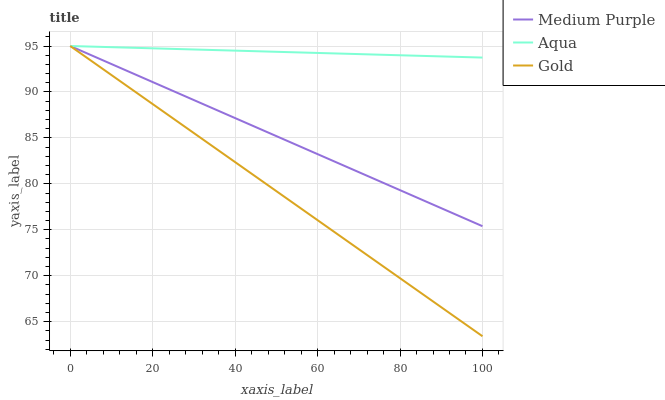Does Gold have the minimum area under the curve?
Answer yes or no. Yes. Does Aqua have the maximum area under the curve?
Answer yes or no. Yes. Does Aqua have the minimum area under the curve?
Answer yes or no. No. Does Gold have the maximum area under the curve?
Answer yes or no. No. Is Aqua the smoothest?
Answer yes or no. Yes. Is Gold the roughest?
Answer yes or no. Yes. Is Gold the smoothest?
Answer yes or no. No. Is Aqua the roughest?
Answer yes or no. No. Does Gold have the lowest value?
Answer yes or no. Yes. Does Aqua have the lowest value?
Answer yes or no. No. Does Gold have the highest value?
Answer yes or no. Yes. Does Aqua intersect Gold?
Answer yes or no. Yes. Is Aqua less than Gold?
Answer yes or no. No. Is Aqua greater than Gold?
Answer yes or no. No. 